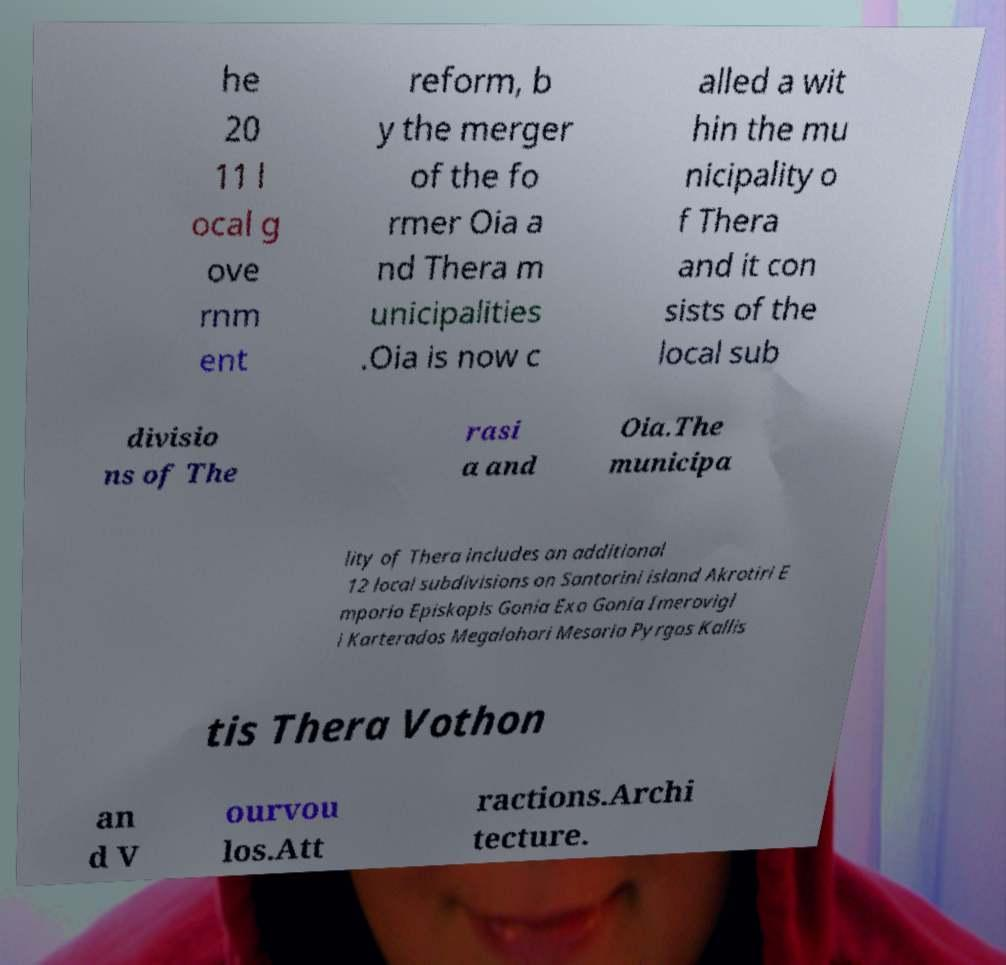Can you accurately transcribe the text from the provided image for me? he 20 11 l ocal g ove rnm ent reform, b y the merger of the fo rmer Oia a nd Thera m unicipalities .Oia is now c alled a wit hin the mu nicipality o f Thera and it con sists of the local sub divisio ns of The rasi a and Oia.The municipa lity of Thera includes an additional 12 local subdivisions on Santorini island Akrotiri E mporio Episkopis Gonia Exo Gonia Imerovigl i Karterados Megalohori Mesaria Pyrgos Kallis tis Thera Vothon an d V ourvou los.Att ractions.Archi tecture. 